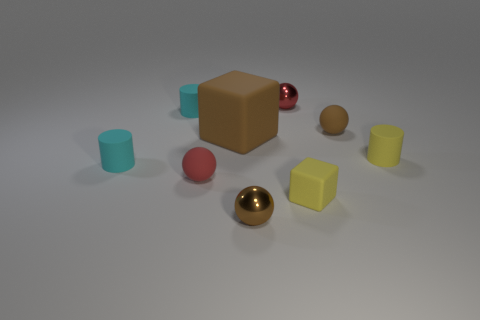Subtract all tiny yellow cylinders. How many cylinders are left? 2 Subtract all yellow cylinders. How many cylinders are left? 2 Add 1 tiny metallic objects. How many objects exist? 10 Subtract all cylinders. How many objects are left? 6 Subtract all cyan matte things. Subtract all tiny cyan cylinders. How many objects are left? 5 Add 7 big matte blocks. How many big matte blocks are left? 8 Add 3 cubes. How many cubes exist? 5 Subtract 0 blue cubes. How many objects are left? 9 Subtract 2 blocks. How many blocks are left? 0 Subtract all blue balls. Subtract all yellow cylinders. How many balls are left? 4 